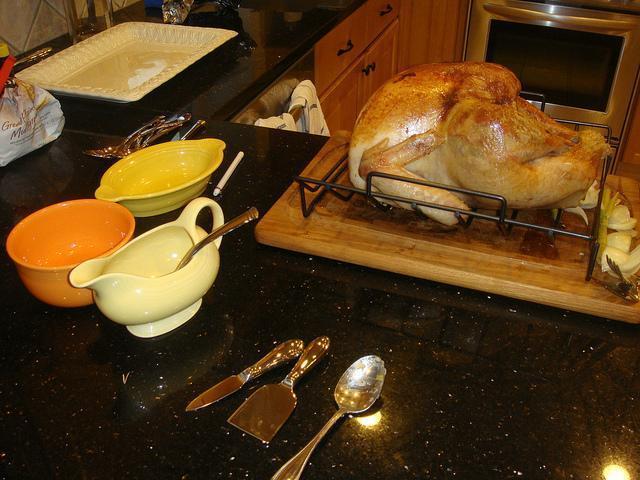How many bowls are visible?
Give a very brief answer. 3. How many pizzas are in this picture?
Give a very brief answer. 0. 